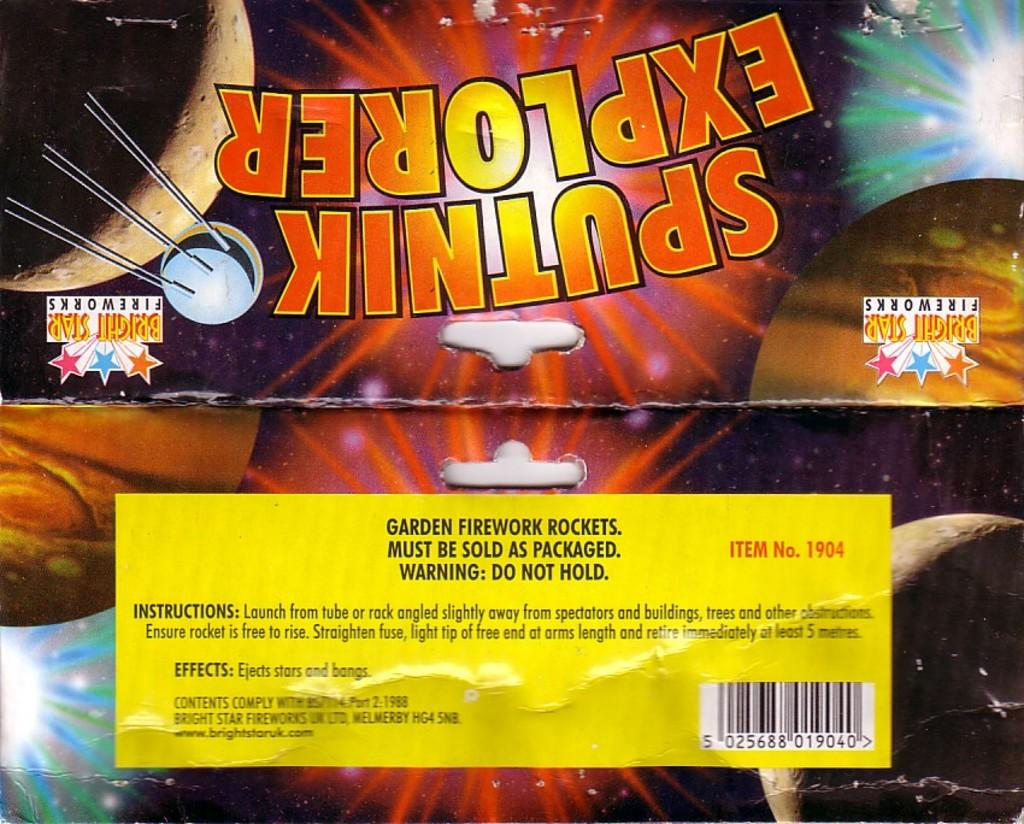<image>
Share a concise interpretation of the image provided. a poster with Sputnik written in the middle of it 